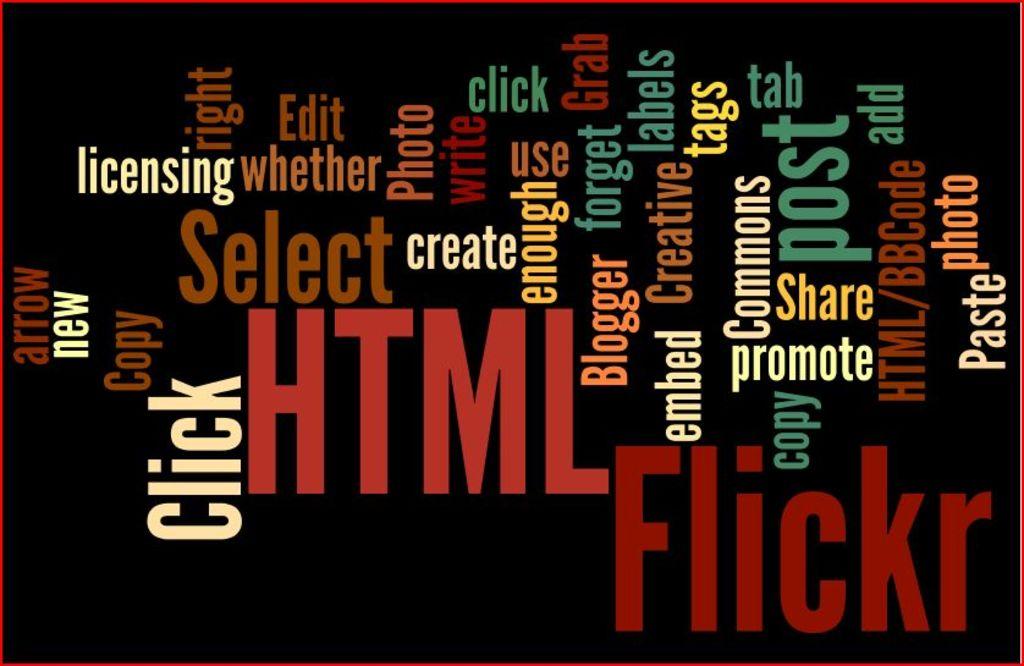Which of these words is (was) actually a name?
Your answer should be very brief. Unanswerable. 